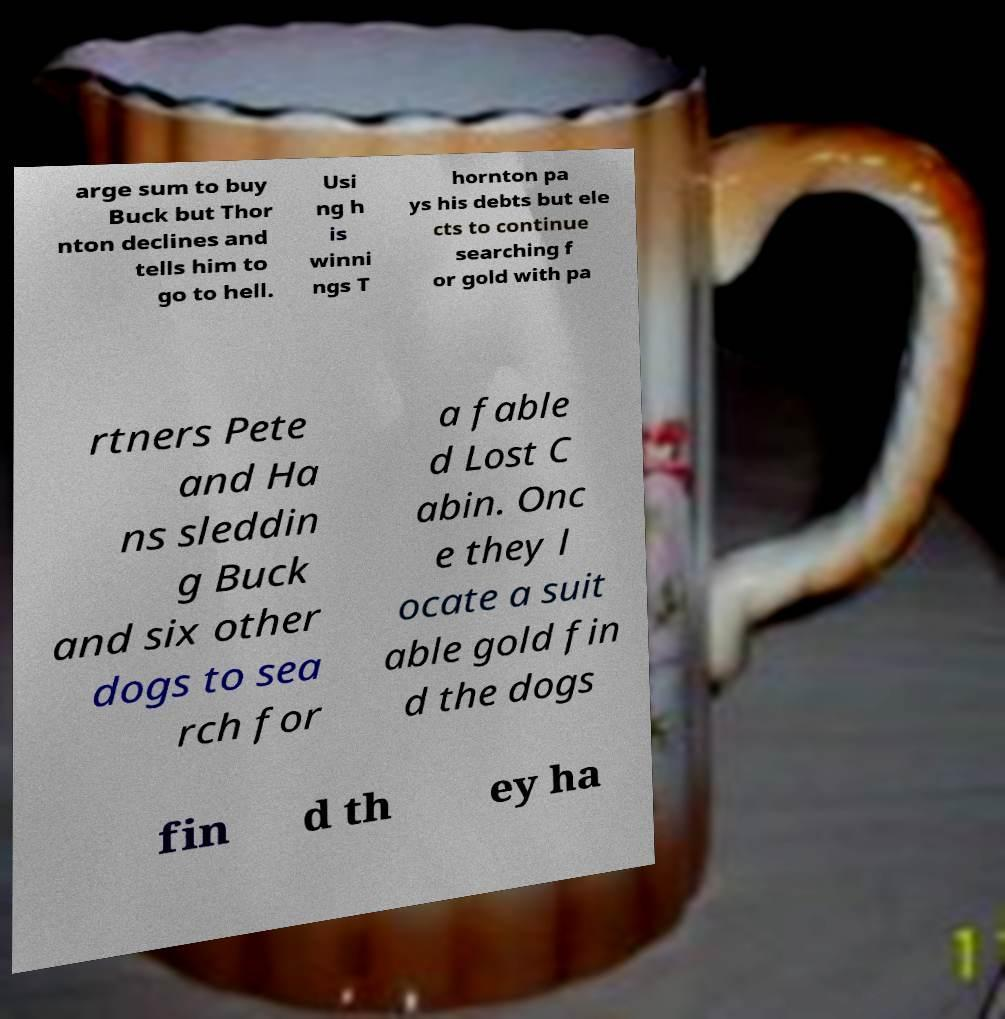Could you extract and type out the text from this image? arge sum to buy Buck but Thor nton declines and tells him to go to hell. Usi ng h is winni ngs T hornton pa ys his debts but ele cts to continue searching f or gold with pa rtners Pete and Ha ns sleddin g Buck and six other dogs to sea rch for a fable d Lost C abin. Onc e they l ocate a suit able gold fin d the dogs fin d th ey ha 